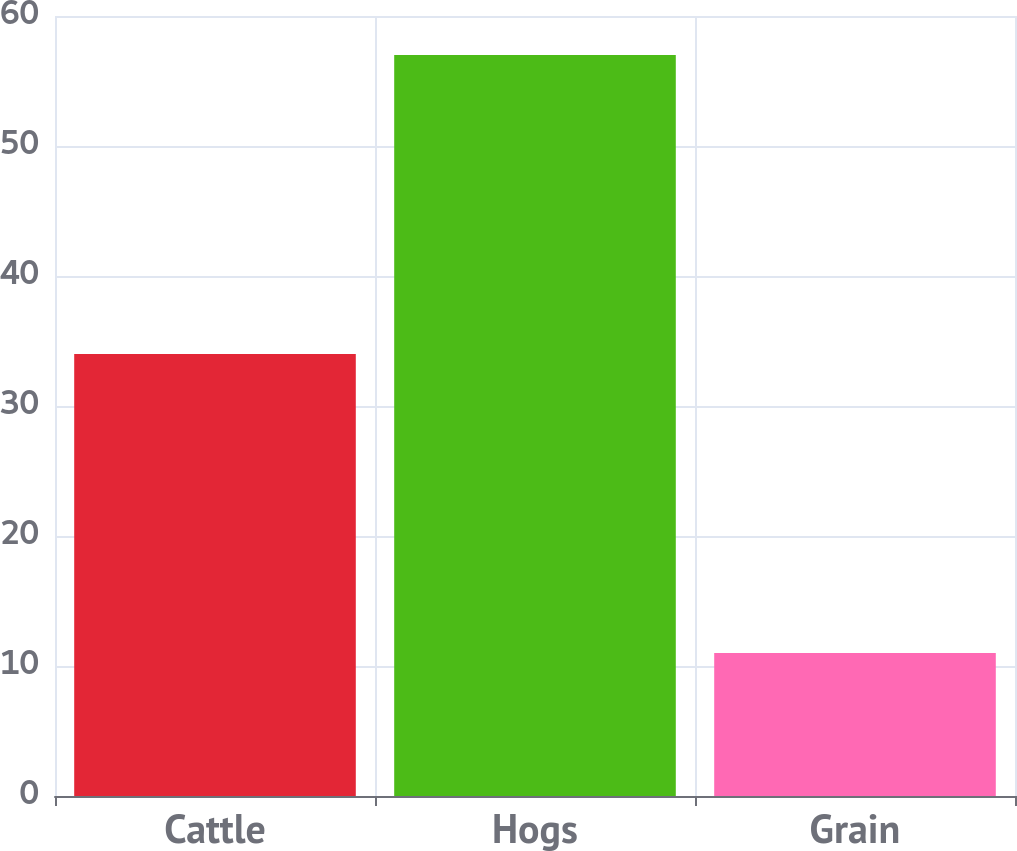Convert chart to OTSL. <chart><loc_0><loc_0><loc_500><loc_500><bar_chart><fcel>Cattle<fcel>Hogs<fcel>Grain<nl><fcel>34<fcel>57<fcel>11<nl></chart> 